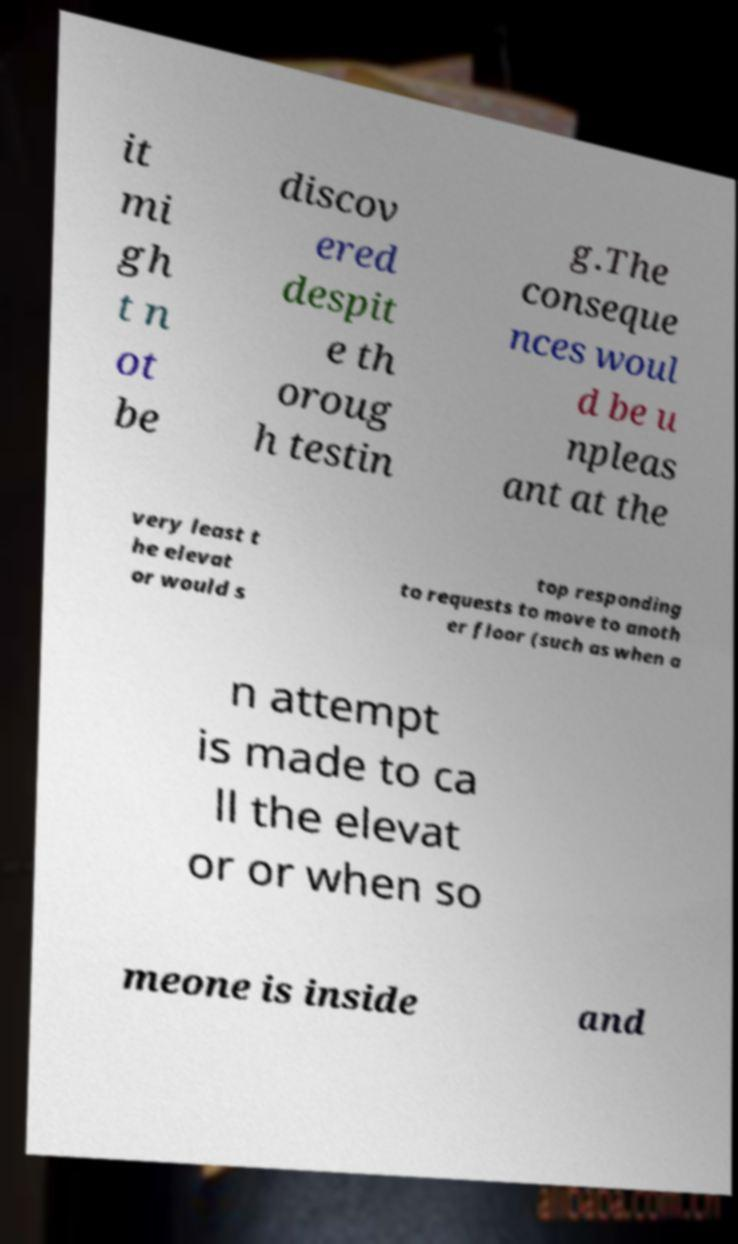What messages or text are displayed in this image? I need them in a readable, typed format. it mi gh t n ot be discov ered despit e th oroug h testin g.The conseque nces woul d be u npleas ant at the very least t he elevat or would s top responding to requests to move to anoth er floor (such as when a n attempt is made to ca ll the elevat or or when so meone is inside and 